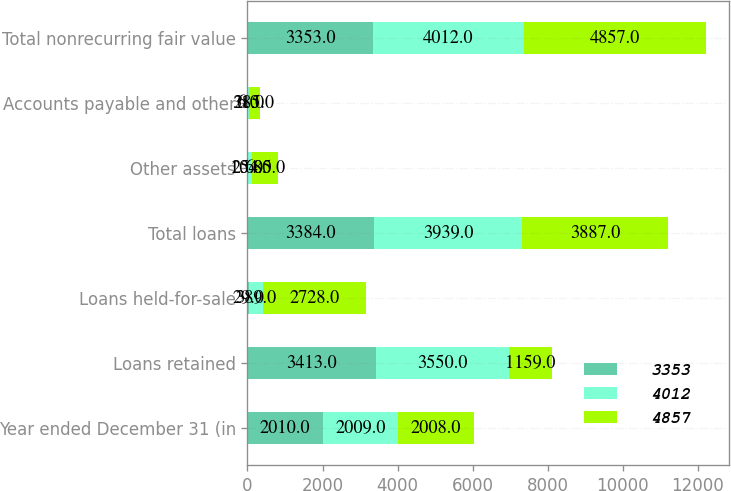Convert chart to OTSL. <chart><loc_0><loc_0><loc_500><loc_500><stacked_bar_chart><ecel><fcel>Year ended December 31 (in<fcel>Loans retained<fcel>Loans held-for-sale<fcel>Total loans<fcel>Other assets<fcel>Accounts payable and other<fcel>Total nonrecurring fair value<nl><fcel>3353<fcel>2010<fcel>3413<fcel>29<fcel>3384<fcel>25<fcel>6<fcel>3353<nl><fcel>4012<fcel>2009<fcel>3550<fcel>389<fcel>3939<fcel>104<fcel>31<fcel>4012<nl><fcel>4857<fcel>2008<fcel>1159<fcel>2728<fcel>3887<fcel>685<fcel>285<fcel>4857<nl></chart> 